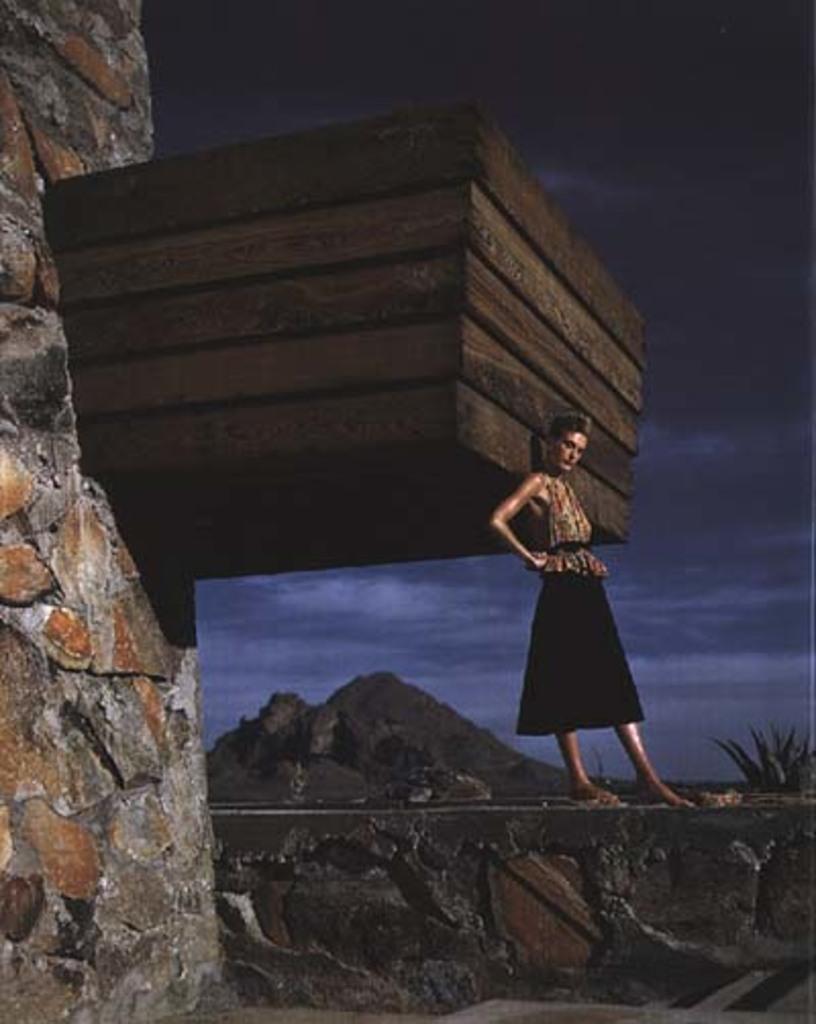Please provide a concise description of this image. In this image I can see a woman wearing brown and black dress is standing and I can see few wooden blocks and a huge structure which is made up of rocks. In the background I can see a mountain, a tree and the sky. 